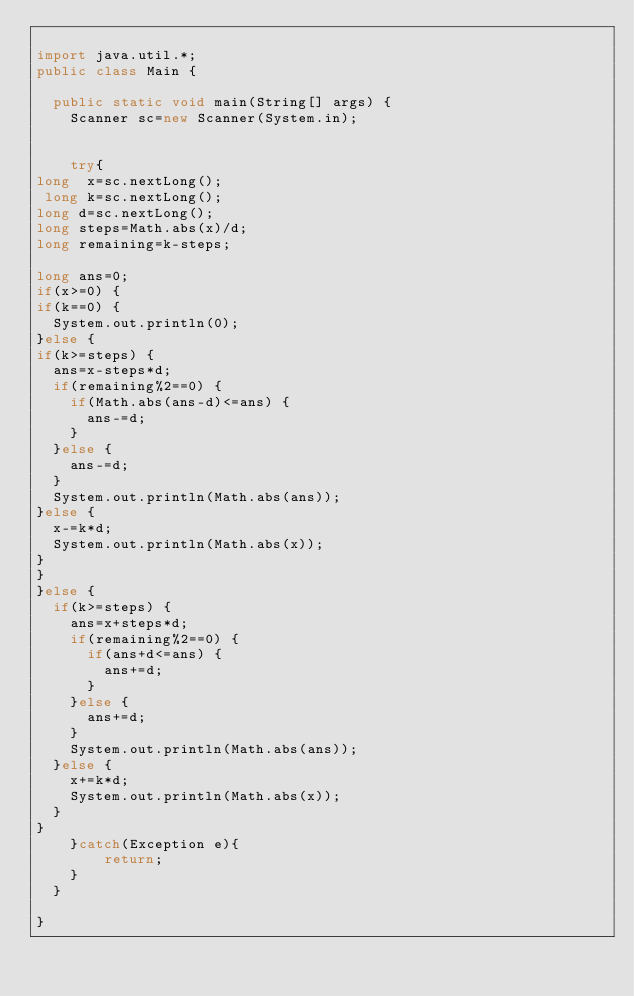Convert code to text. <code><loc_0><loc_0><loc_500><loc_500><_Java_>
import java.util.*;
public class Main {

	public static void main(String[] args) {
		Scanner sc=new Scanner(System.in);


		try{
long  x=sc.nextLong();
 long k=sc.nextLong();
long d=sc.nextLong();
long steps=Math.abs(x)/d;
long remaining=k-steps;

long ans=0;
if(x>=0) {
if(k==0) {
	System.out.println(0);
}else {
if(k>=steps) {
	ans=x-steps*d;
	if(remaining%2==0) {
		if(Math.abs(ans-d)<=ans) {
			ans-=d;
		}
	}else {
		ans-=d;
	}
	System.out.println(Math.abs(ans));
}else {
	x-=k*d;
	System.out.println(Math.abs(x));
}
}
}else {
	if(k>=steps) {
		ans=x+steps*d;
		if(remaining%2==0) {
			if(ans+d<=ans) {
				ans+=d;
			}
		}else {
			ans+=d;
		}
		System.out.println(Math.abs(ans));
	}else {
		x+=k*d;
		System.out.println(Math.abs(x));
	}
}
		}catch(Exception e){
		    return;
		}
	}

}
</code> 